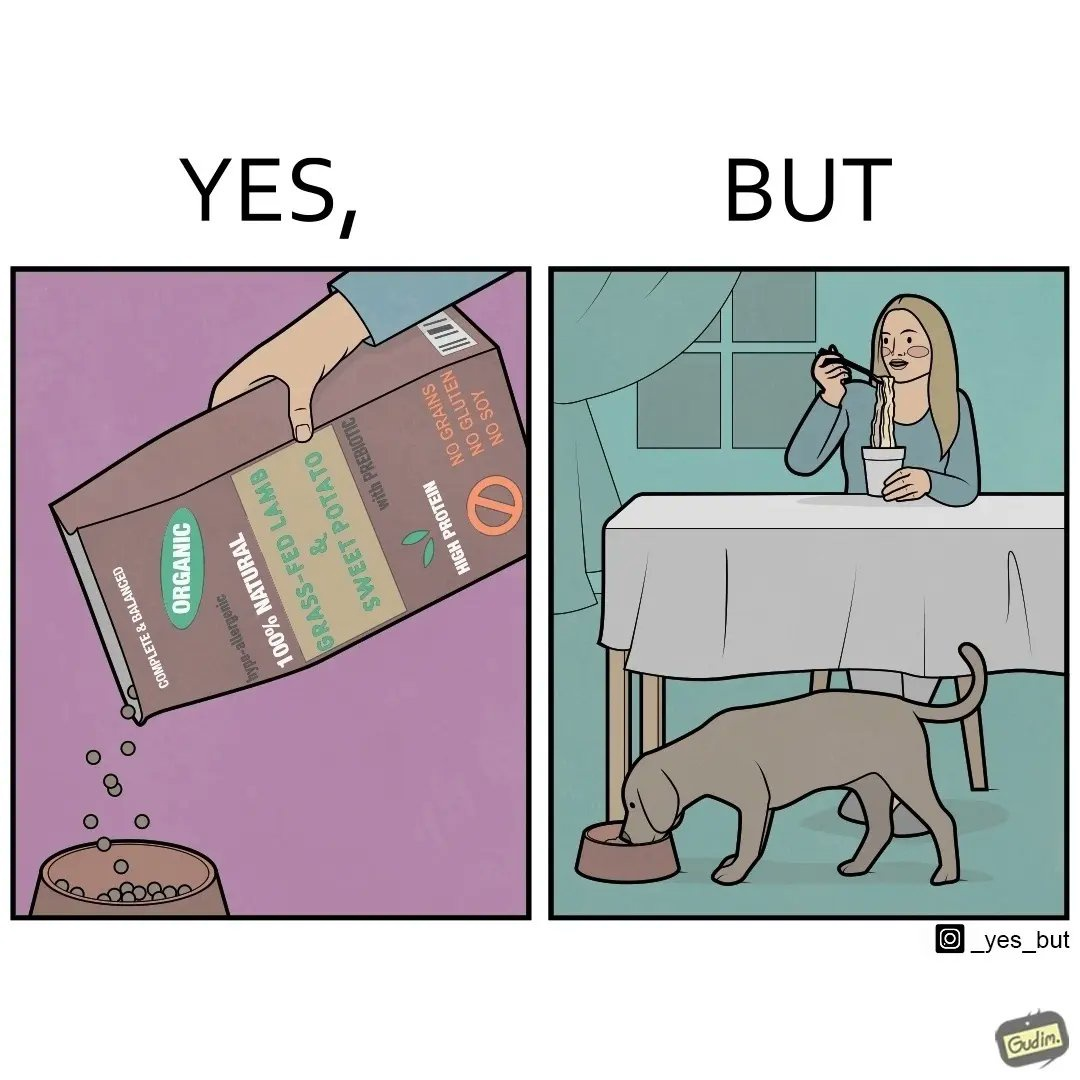What is shown in the left half versus the right half of this image? In the left part of the image: The image shows food grains being poured into a bowl from the packet. The packet says "Complete & Balanced", "Organic", "100% Natural", "Grass Fed Lamb & Sweet Potato" , "With Prebiotic", "High Protein", "No grains", "No Gluten" and "No Soy". In the right part of the image: The image shows a dog eating food from its bowl on the floor and a woman eating noodles from a cup on the table. 